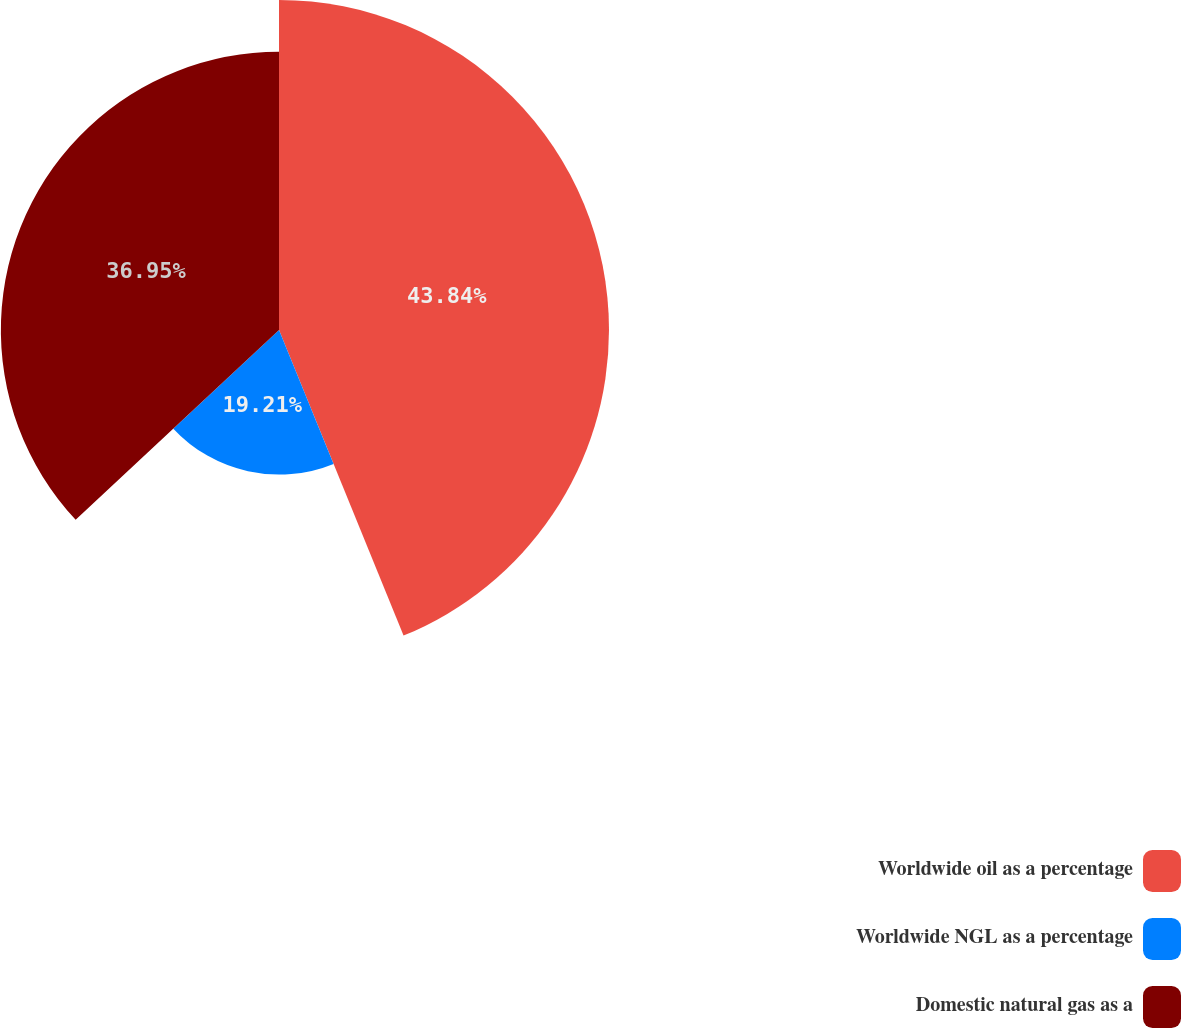Convert chart to OTSL. <chart><loc_0><loc_0><loc_500><loc_500><pie_chart><fcel>Worldwide oil as a percentage<fcel>Worldwide NGL as a percentage<fcel>Domestic natural gas as a<nl><fcel>43.84%<fcel>19.21%<fcel>36.95%<nl></chart> 